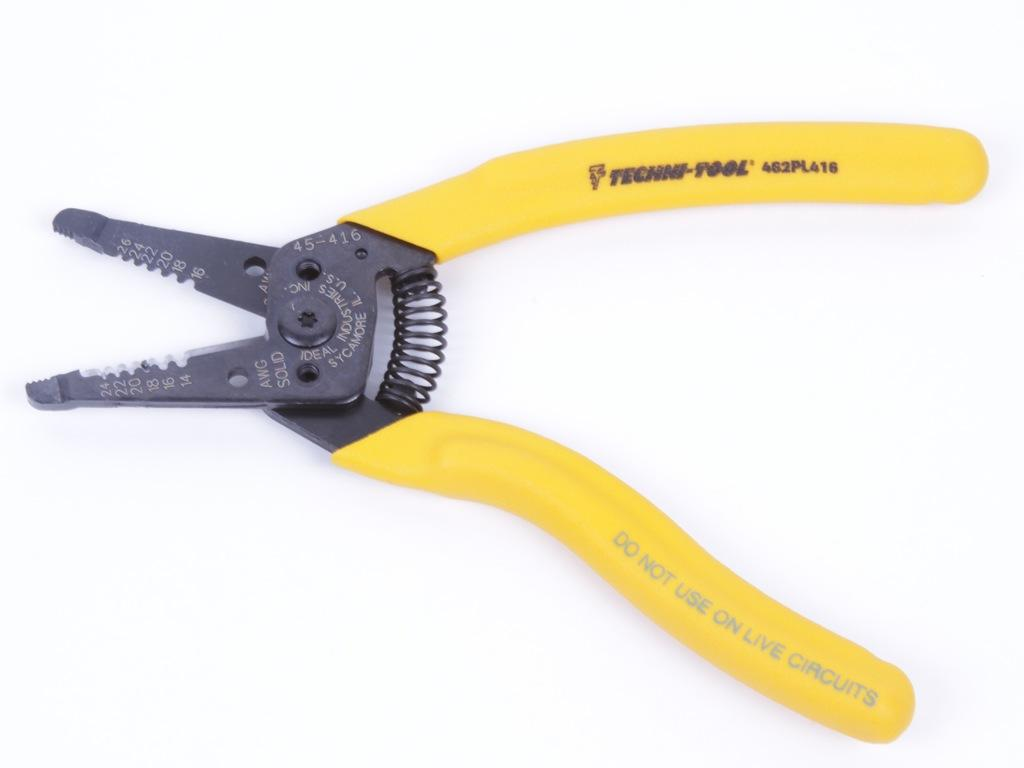<image>
Write a terse but informative summary of the picture. A yellow grip pliers tool with the writing Techni-Tool on one handle 